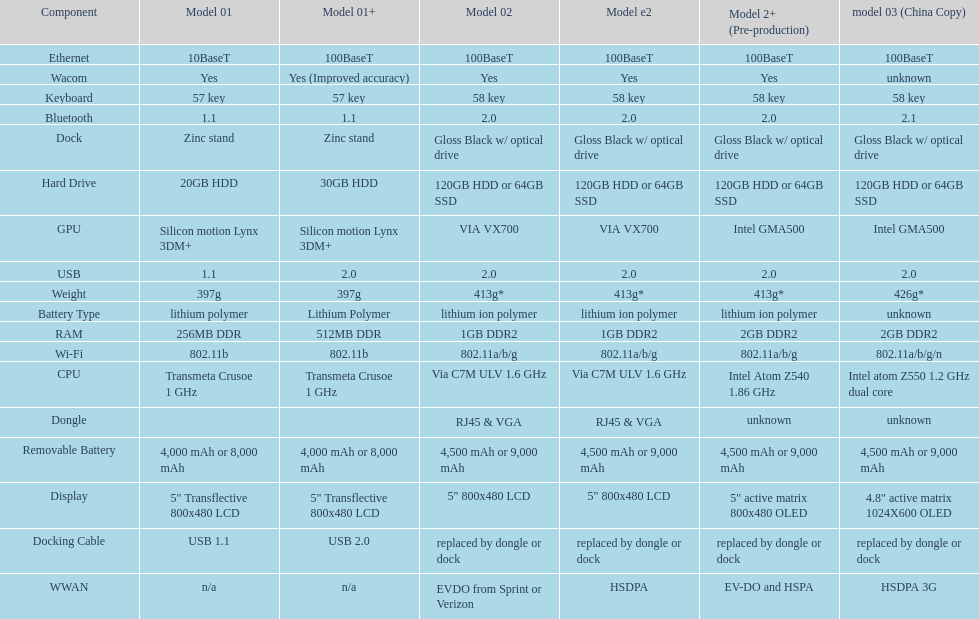What is the next highest hard drive available after the 30gb model? 64GB SSD. 